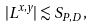Convert formula to latex. <formula><loc_0><loc_0><loc_500><loc_500>| L ^ { x , y } | \lesssim S _ { P , D } \, ,</formula> 